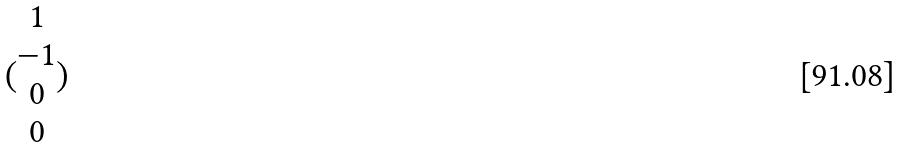<formula> <loc_0><loc_0><loc_500><loc_500>( \begin{matrix} 1 \\ - 1 \\ 0 \\ 0 \end{matrix} )</formula> 